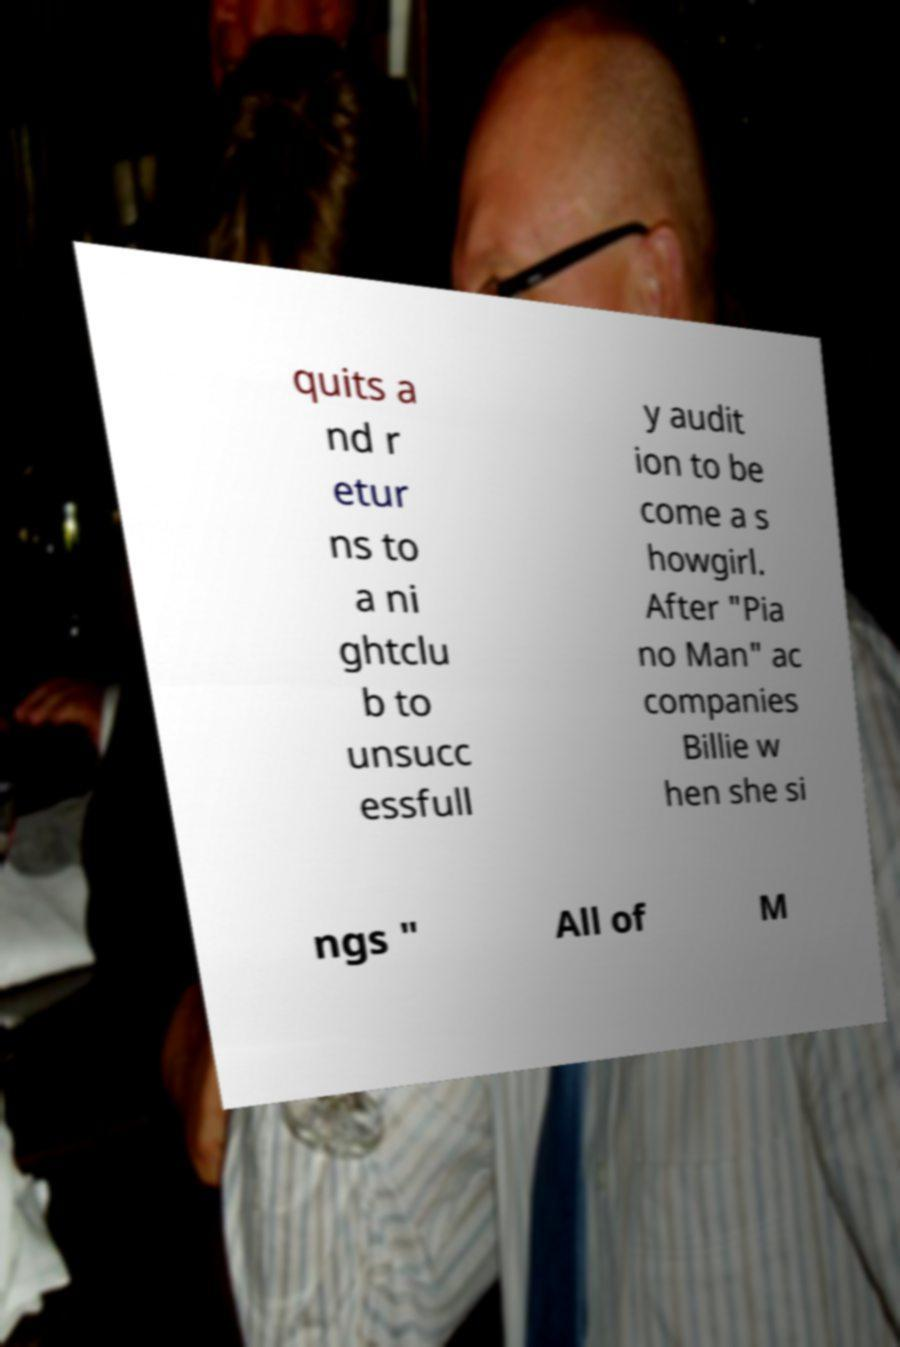Could you extract and type out the text from this image? quits a nd r etur ns to a ni ghtclu b to unsucc essfull y audit ion to be come a s howgirl. After "Pia no Man" ac companies Billie w hen she si ngs " All of M 